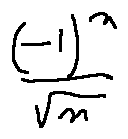Convert formula to latex. <formula><loc_0><loc_0><loc_500><loc_500>\frac { ( - 1 ) ^ { n } } { \sqrt { n } }</formula> 